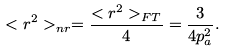Convert formula to latex. <formula><loc_0><loc_0><loc_500><loc_500>< r ^ { 2 } > _ { n r } = \frac { < r ^ { 2 } > _ { F T } } { 4 } = \frac { 3 } { 4 p _ { a } ^ { 2 } } .</formula> 